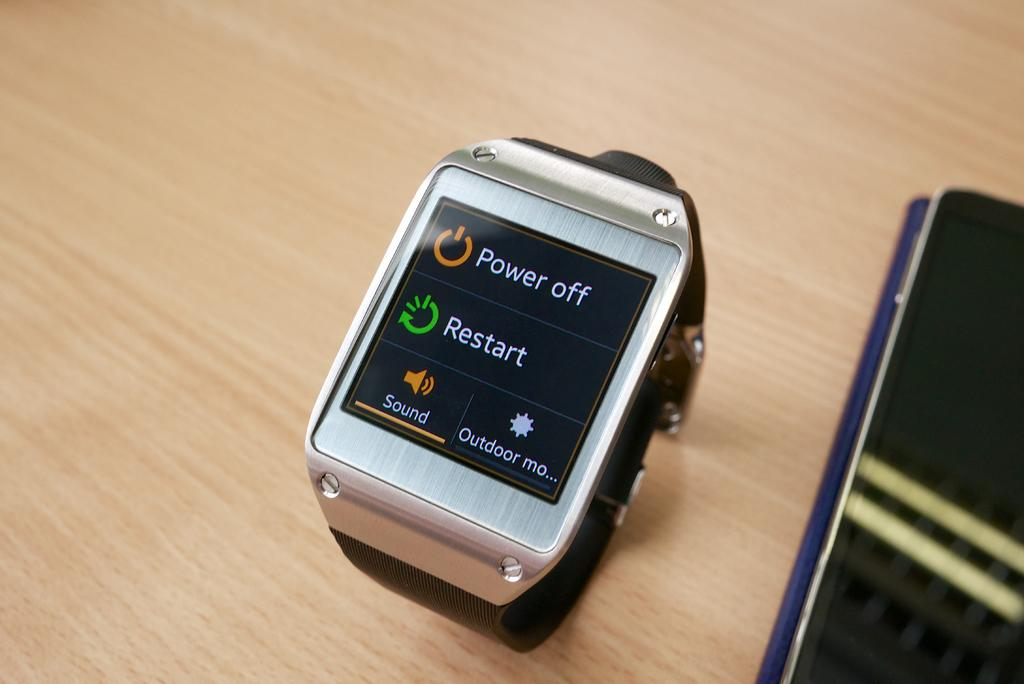<image>
Summarize the visual content of the image. A smart watch with the screen on and showing power off and restart options. 